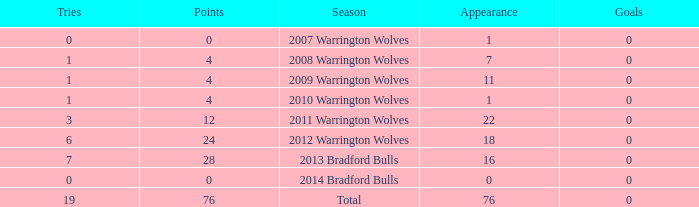What is the average tries for the season 2008 warrington wolves with an appearance more than 7? None. 